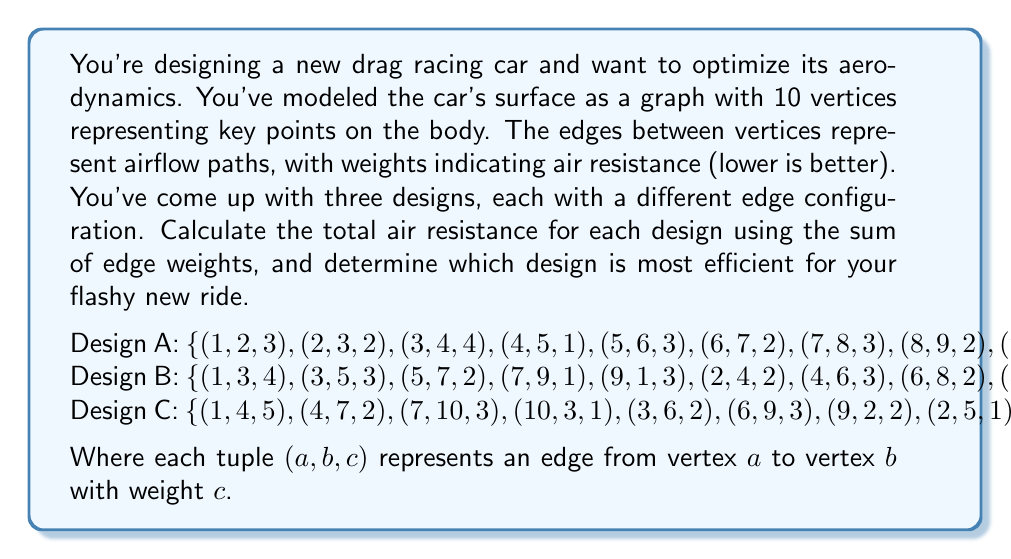Solve this math problem. To solve this problem, we need to calculate the total air resistance for each design by summing the weights of all edges in each graph. Let's break it down step by step:

1. Design A:
   Sum of weights = 3 + 2 + 4 + 1 + 3 + 2 + 3 + 2 + 1 + 4 = 25

2. Design B:
   Sum of weights = 4 + 3 + 2 + 1 + 3 + 2 + 3 + 2 + 1 + 4 = 25

3. Design C:
   Sum of weights = 5 + 2 + 3 + 1 + 2 + 3 + 2 + 1 + 3 + 3 = 25

Interestingly, all three designs have the same total air resistance of 25. However, the distribution of resistance is different in each design, which could affect the car's performance in different ways.

To determine which design is most efficient, we need to consider not just the total resistance, but also how it's distributed. In drag racing, reducing frontal air resistance is crucial. Assuming vertex 1 represents the front of the car:

- Design A has a moderate front resistance (edge weight 3)
- Design B has a higher front resistance (edge weight 4)
- Design C has the highest front resistance (edge weight 5)

Therefore, despite having the same total resistance, Design A would likely be the most efficient for drag racing due to its lower frontal air resistance.
Answer: All three designs have a total air resistance of 25. However, Design A is the most efficient for drag racing due to its lower frontal air resistance. 